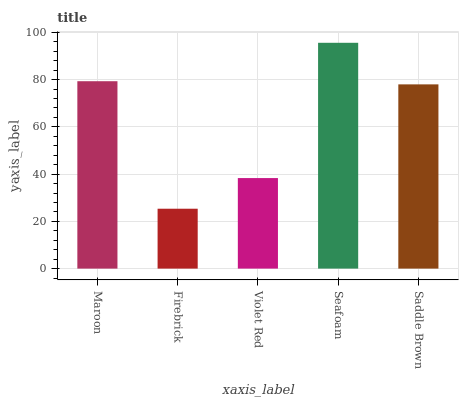Is Firebrick the minimum?
Answer yes or no. Yes. Is Seafoam the maximum?
Answer yes or no. Yes. Is Violet Red the minimum?
Answer yes or no. No. Is Violet Red the maximum?
Answer yes or no. No. Is Violet Red greater than Firebrick?
Answer yes or no. Yes. Is Firebrick less than Violet Red?
Answer yes or no. Yes. Is Firebrick greater than Violet Red?
Answer yes or no. No. Is Violet Red less than Firebrick?
Answer yes or no. No. Is Saddle Brown the high median?
Answer yes or no. Yes. Is Saddle Brown the low median?
Answer yes or no. Yes. Is Violet Red the high median?
Answer yes or no. No. Is Maroon the low median?
Answer yes or no. No. 